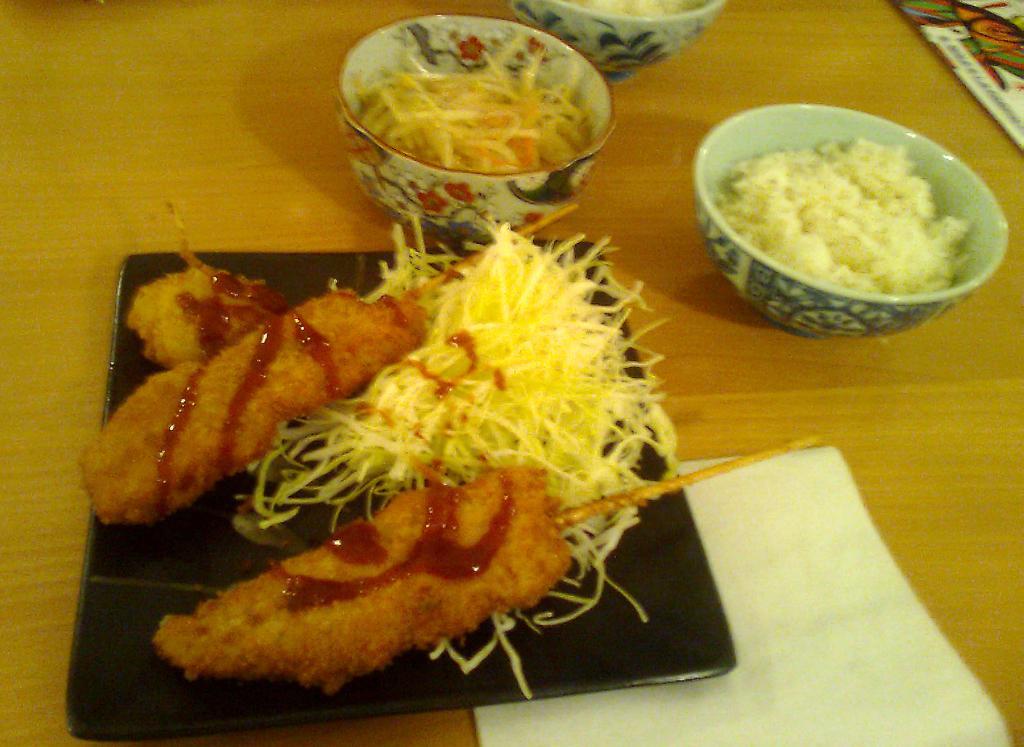Can you describe this image briefly? In this picture I can see a black color thing, on which there is food, which is of brown, yellow and red color. I can also see few bowls in which there is food. On the bottom right of this picture I can see a white color paper and I see that all these things are on the brown color surface. 